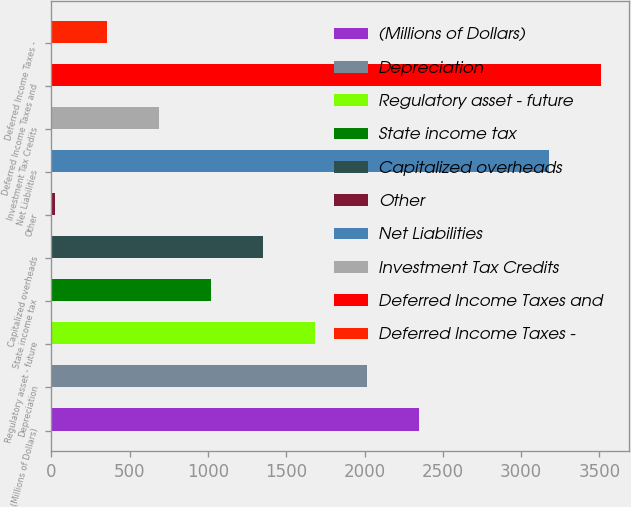Convert chart to OTSL. <chart><loc_0><loc_0><loc_500><loc_500><bar_chart><fcel>(Millions of Dollars)<fcel>Depreciation<fcel>Regulatory asset - future<fcel>State income tax<fcel>Capitalized overheads<fcel>Other<fcel>Net Liabilities<fcel>Investment Tax Credits<fcel>Deferred Income Taxes and<fcel>Deferred Income Taxes -<nl><fcel>2349.4<fcel>2017.2<fcel>1685<fcel>1020.6<fcel>1352.8<fcel>24<fcel>3180<fcel>688.4<fcel>3512.2<fcel>356.2<nl></chart> 